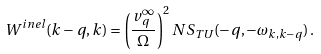<formula> <loc_0><loc_0><loc_500><loc_500>W ^ { i n e l } ( { k - q , k } ) = \left ( \frac { v _ { q } ^ { \infty } } { \Omega } \right ) ^ { 2 } N S _ { T U } ( - { q } , - \omega _ { k , k - q } ) \, .</formula> 